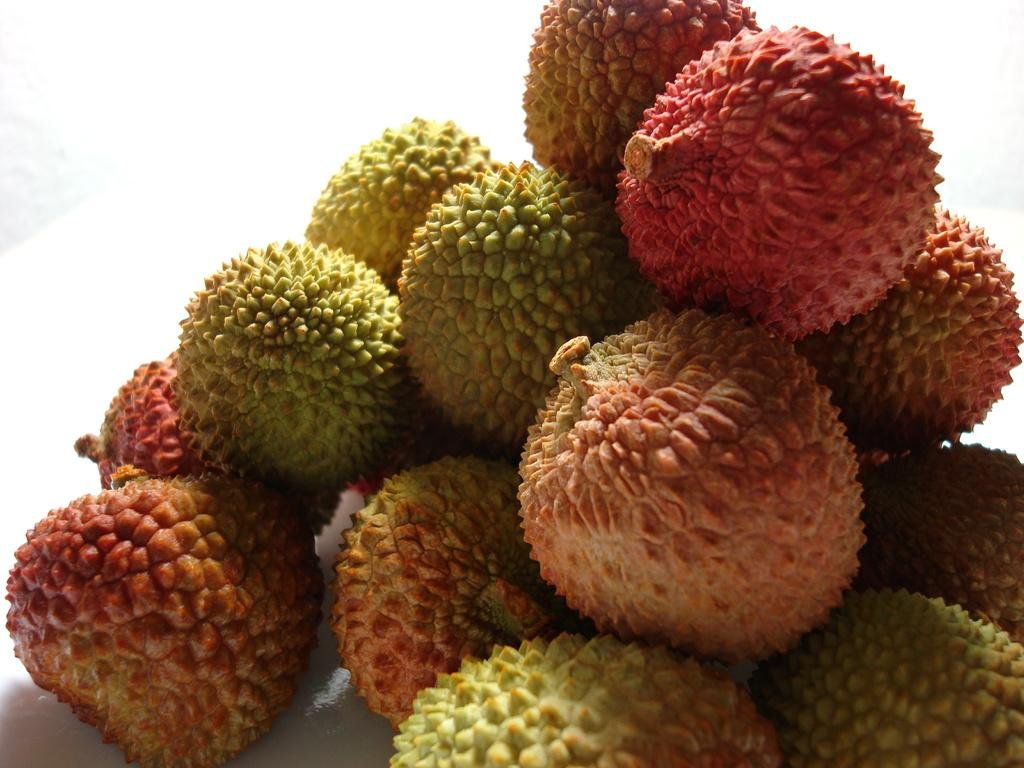What type of fruits are in the picture? There are lychee fruits in the picture. Can you describe the appearance of the lychee fruits? The lychee fruits have different colors. What type of sidewalk can be seen in the picture? There is no sidewalk present in the picture; it features lychee fruits with different colors. 